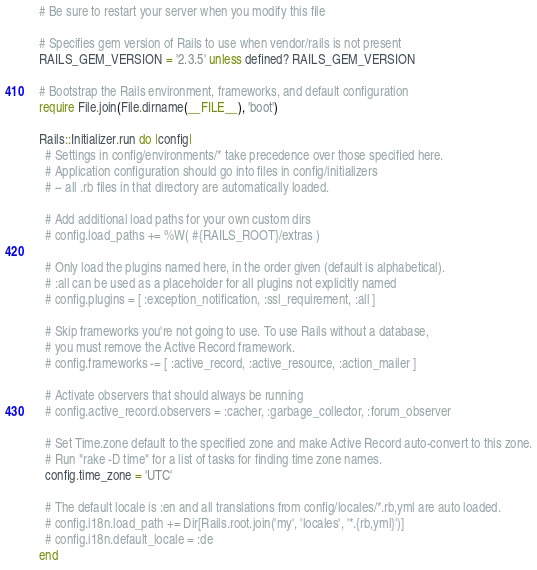Convert code to text. <code><loc_0><loc_0><loc_500><loc_500><_Ruby_># Be sure to restart your server when you modify this file

# Specifies gem version of Rails to use when vendor/rails is not present
RAILS_GEM_VERSION = '2.3.5' unless defined? RAILS_GEM_VERSION

# Bootstrap the Rails environment, frameworks, and default configuration
require File.join(File.dirname(__FILE__), 'boot')

Rails::Initializer.run do |config|
  # Settings in config/environments/* take precedence over those specified here.
  # Application configuration should go into files in config/initializers
  # -- all .rb files in that directory are automatically loaded.

  # Add additional load paths for your own custom dirs
  # config.load_paths += %W( #{RAILS_ROOT}/extras )

  # Only load the plugins named here, in the order given (default is alphabetical).
  # :all can be used as a placeholder for all plugins not explicitly named
  # config.plugins = [ :exception_notification, :ssl_requirement, :all ]

  # Skip frameworks you're not going to use. To use Rails without a database,
  # you must remove the Active Record framework.
  # config.frameworks -= [ :active_record, :active_resource, :action_mailer ]

  # Activate observers that should always be running
  # config.active_record.observers = :cacher, :garbage_collector, :forum_observer

  # Set Time.zone default to the specified zone and make Active Record auto-convert to this zone.
  # Run "rake -D time" for a list of tasks for finding time zone names.
  config.time_zone = 'UTC'

  # The default locale is :en and all translations from config/locales/*.rb,yml are auto loaded.
  # config.i18n.load_path += Dir[Rails.root.join('my', 'locales', '*.{rb,yml}')]
  # config.i18n.default_locale = :de
end
</code> 